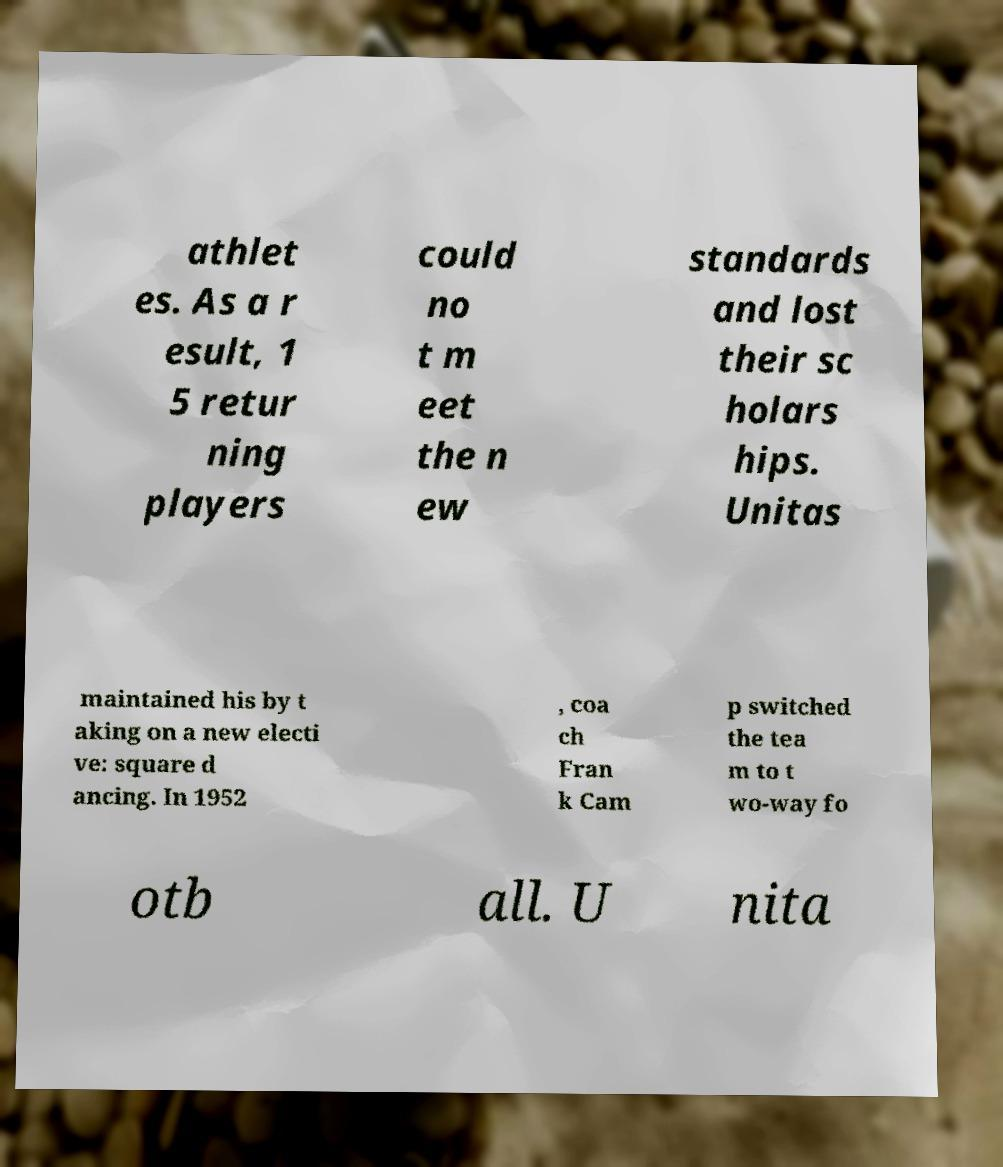What messages or text are displayed in this image? I need them in a readable, typed format. athlet es. As a r esult, 1 5 retur ning players could no t m eet the n ew standards and lost their sc holars hips. Unitas maintained his by t aking on a new electi ve: square d ancing. In 1952 , coa ch Fran k Cam p switched the tea m to t wo-way fo otb all. U nita 